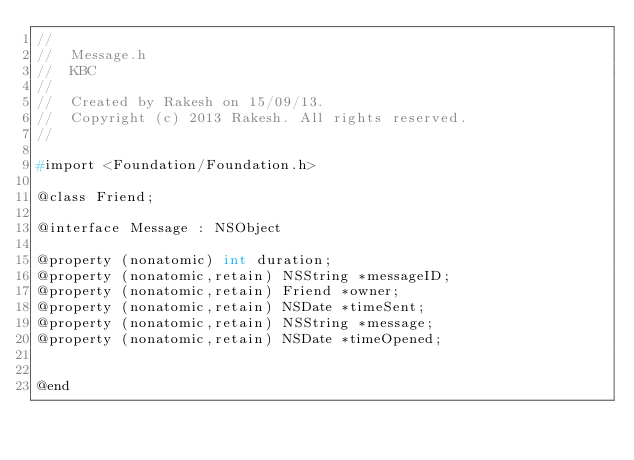<code> <loc_0><loc_0><loc_500><loc_500><_C_>//
//  Message.h
//  KBC
//
//  Created by Rakesh on 15/09/13.
//  Copyright (c) 2013 Rakesh. All rights reserved.
//

#import <Foundation/Foundation.h>

@class Friend;

@interface Message : NSObject

@property (nonatomic) int duration;
@property (nonatomic,retain) NSString *messageID;
@property (nonatomic,retain) Friend *owner;
@property (nonatomic,retain) NSDate *timeSent;
@property (nonatomic,retain) NSString *message;
@property (nonatomic,retain) NSDate *timeOpened;


@end
</code> 